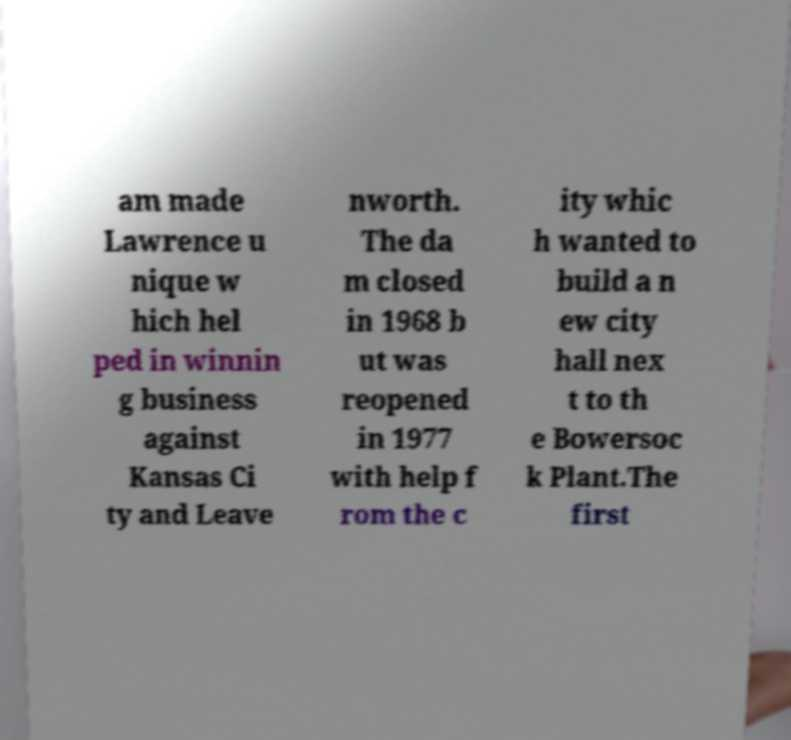Please read and relay the text visible in this image. What does it say? am made Lawrence u nique w hich hel ped in winnin g business against Kansas Ci ty and Leave nworth. The da m closed in 1968 b ut was reopened in 1977 with help f rom the c ity whic h wanted to build a n ew city hall nex t to th e Bowersoc k Plant.The first 